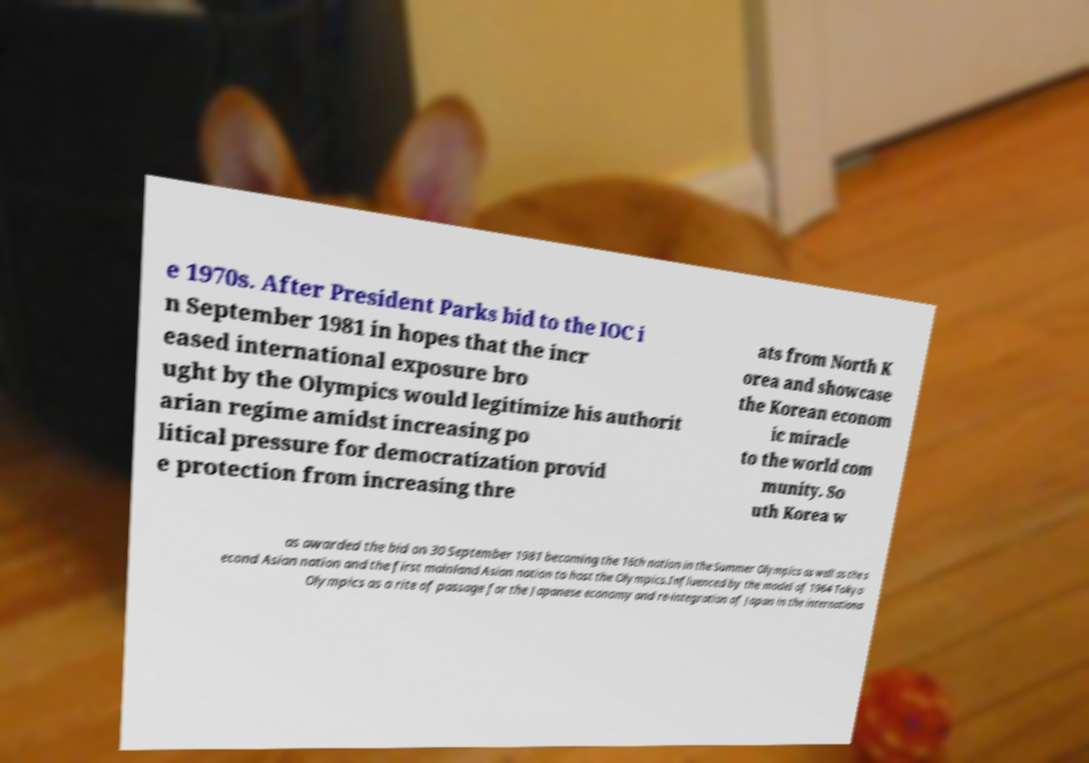Could you extract and type out the text from this image? e 1970s. After President Parks bid to the IOC i n September 1981 in hopes that the incr eased international exposure bro ught by the Olympics would legitimize his authorit arian regime amidst increasing po litical pressure for democratization provid e protection from increasing thre ats from North K orea and showcase the Korean econom ic miracle to the world com munity. So uth Korea w as awarded the bid on 30 September 1981 becoming the 16th nation in the Summer Olympics as well as the s econd Asian nation and the first mainland Asian nation to host the Olympics.Influenced by the model of 1964 Tokyo Olympics as a rite of passage for the Japanese economy and re-integration of Japan in the internationa 